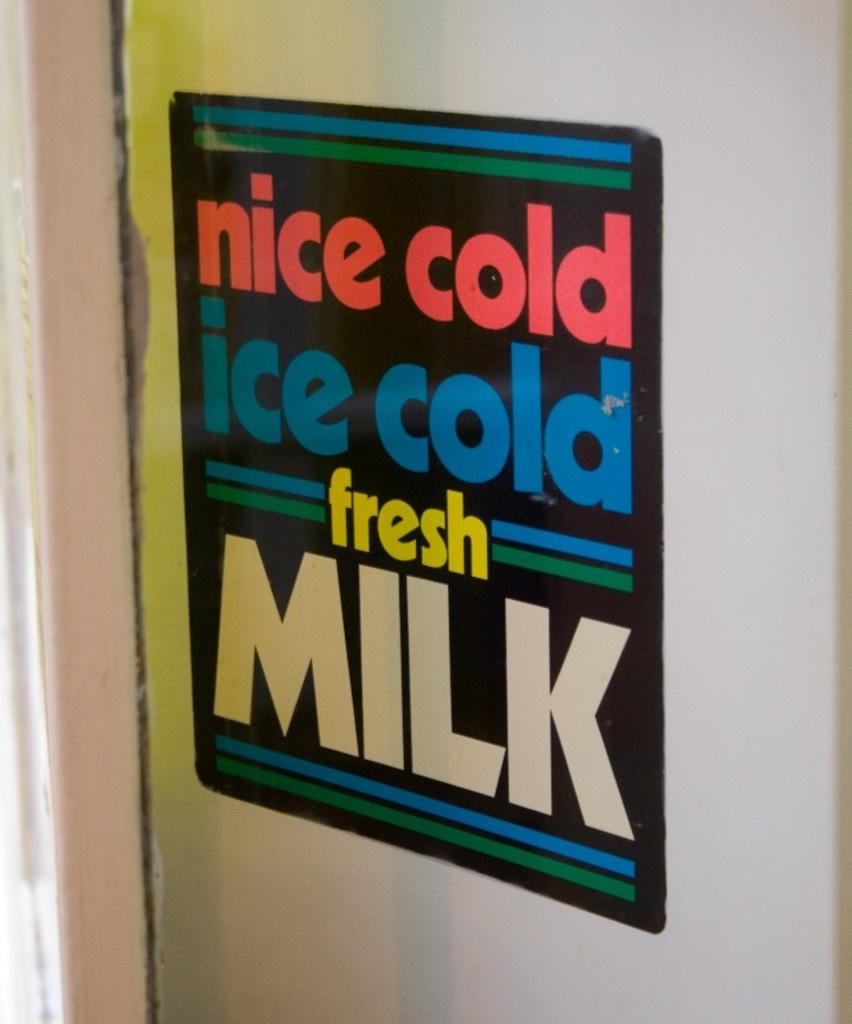<image>
Share a concise interpretation of the image provided. a sign for nice cole, ice cold, fresh milk is black with red and blue writing 